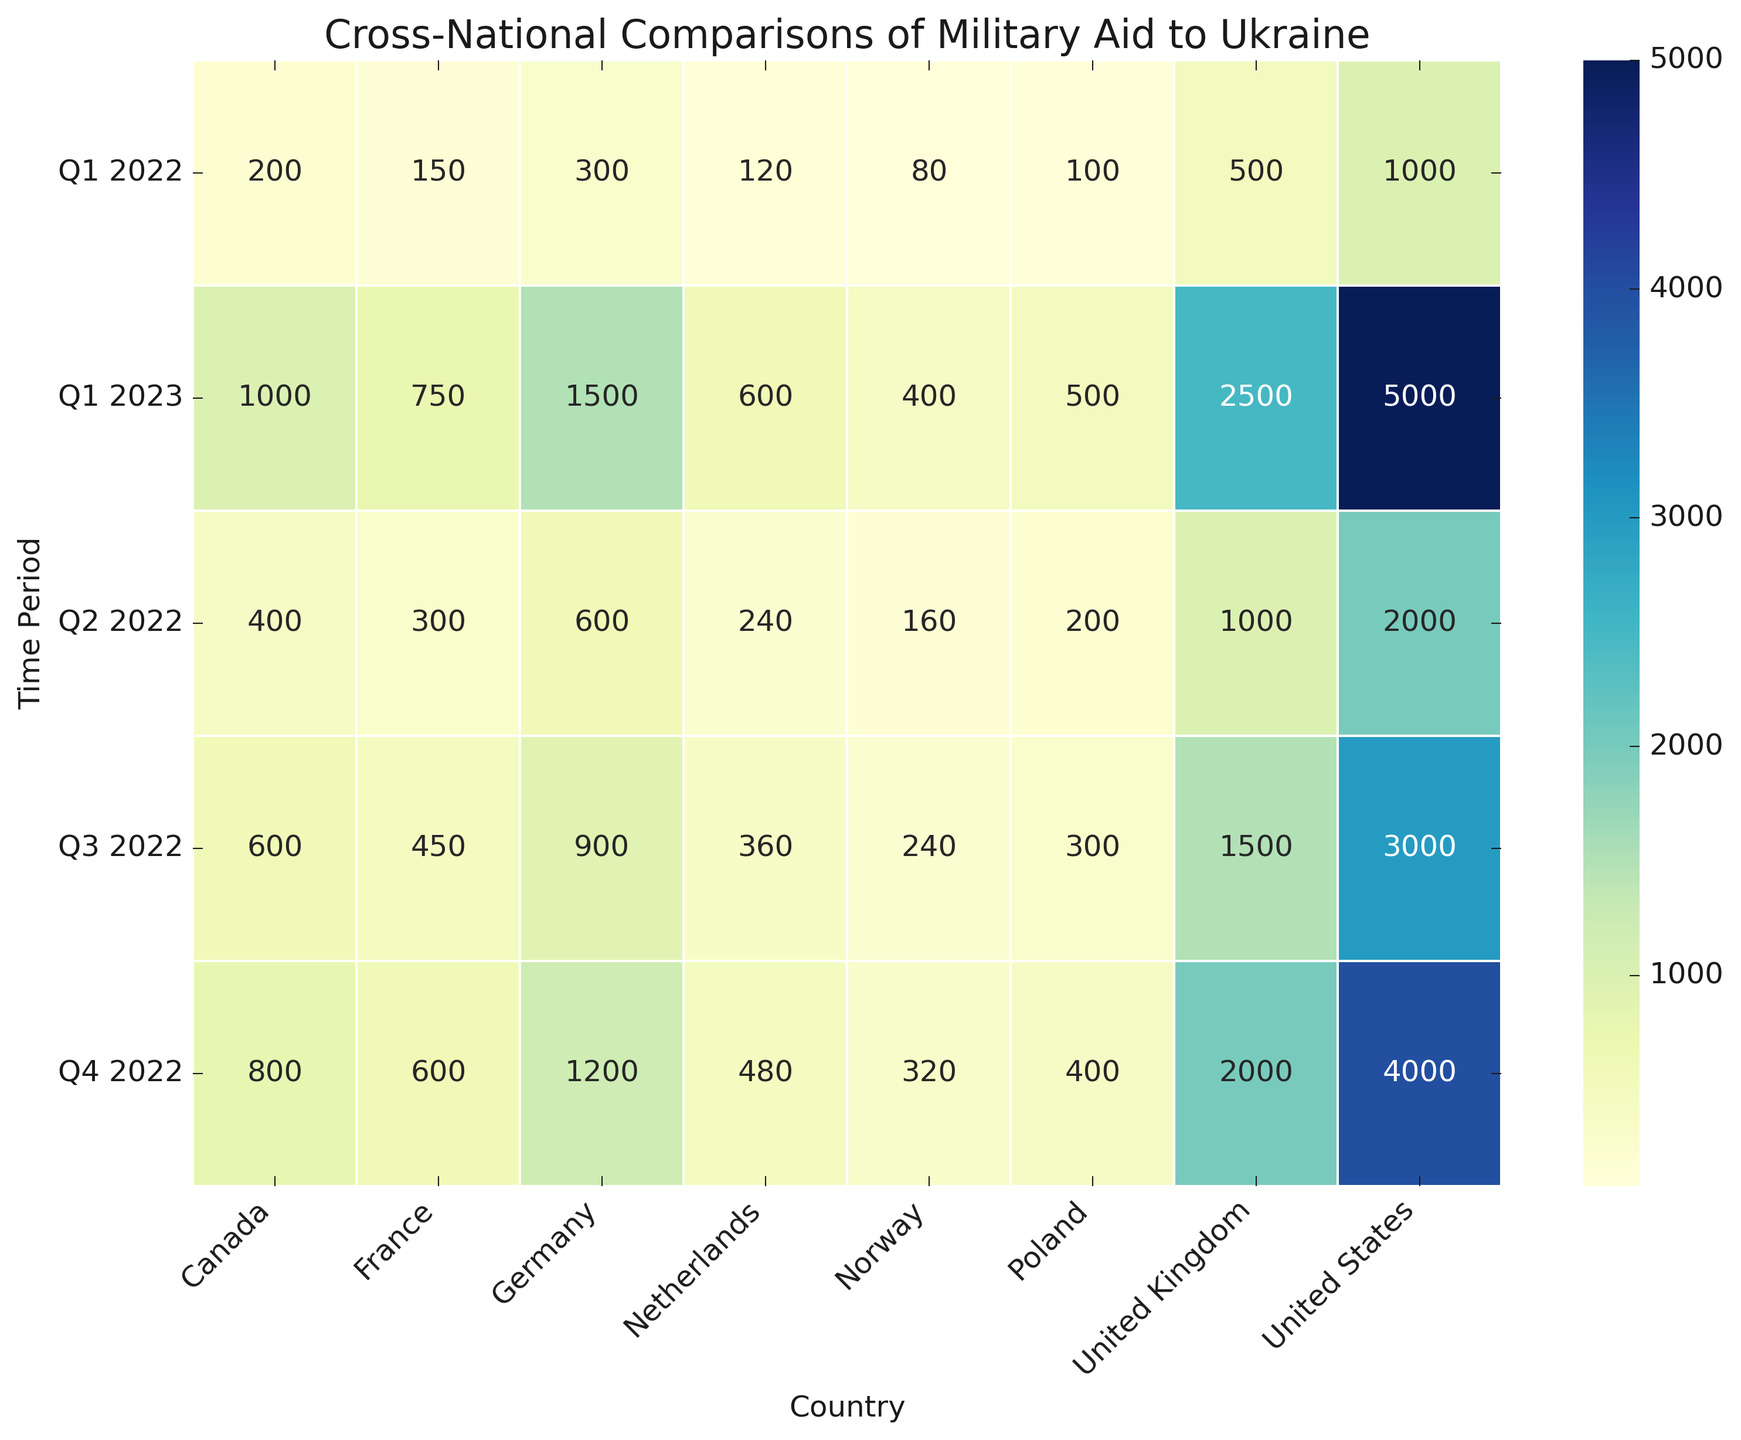What country provided the highest amount of military aid to Ukraine in Q1 2023? Look at the Q1 2023 row and compare the values for each country. The United States provided 5000 million USD, which is the highest amount.
Answer: United States Which country had the smallest increase in military aid from Q1 2022 to Q1 2023? Compare the differences between Q1 2022 and Q1 2023 for each country. Norway increased from 80 to 400 million USD, an increase of 320 million USD. This is the smallest absolute increase compared to other countries.
Answer: Norway What is the total military aid given by Canada over all time periods? Sum the values in the column for Canada: 200 + 400 + 600 + 800 + 1000 = 3000 million USD.
Answer: 3000 Which country showed the most consistent increase in aid across all time periods? Look for a country whose aid increases by a similar amount across successive time periods. Both Germany and Canada have uniform 300 and 200 million USD increments, respectively, but the amount increase for Canada is more consistent relative to its starting point.
Answer: Canada How much more aid did Germany provide in Q4 2022 compared to Q2 2022? Subtract the aid amount in Q2 2022 from Q4 2022 for Germany: 1200 - 600 = 600 million USD.
Answer: 600 Which countries provided more aid in Q2 2022 compared to Q1 2022? Compare each country's aid amount in Q2 2022 to Q1 2022. The countries which increased their aid are the United States, United Kingdom, Germany, Canada, Poland, France, Netherlands, and Norway.
Answer: United States, United Kingdom, Germany, Canada, Poland, France, Netherlands, Norway What is the average military aid amount given by the United Kingdom over all time periods? Sum the values in the column for the United Kingdom and divide by the number of periods: (500 + 1000 + 1500 + 2000 + 2500)/5 = 1500 million USD.
Answer: 1500 